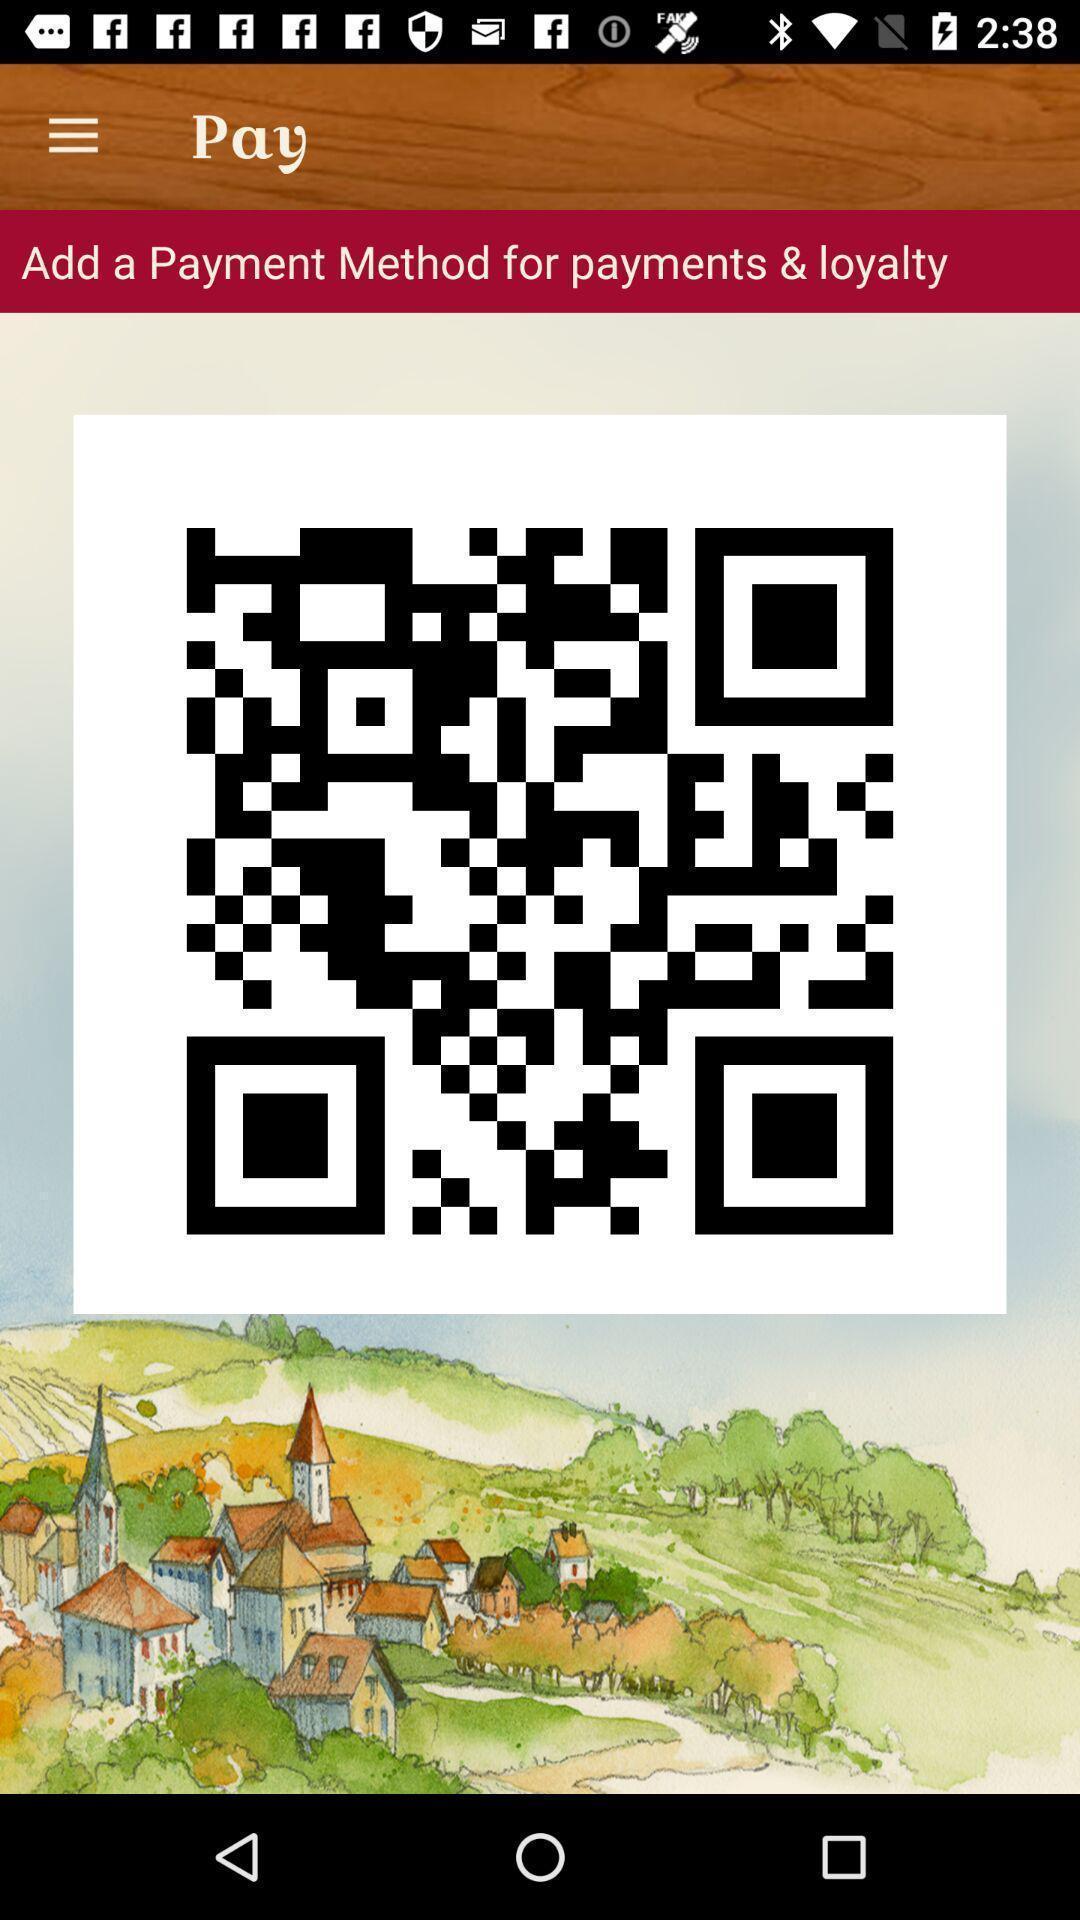What can you discern from this picture? Page showing qr code to pay. 